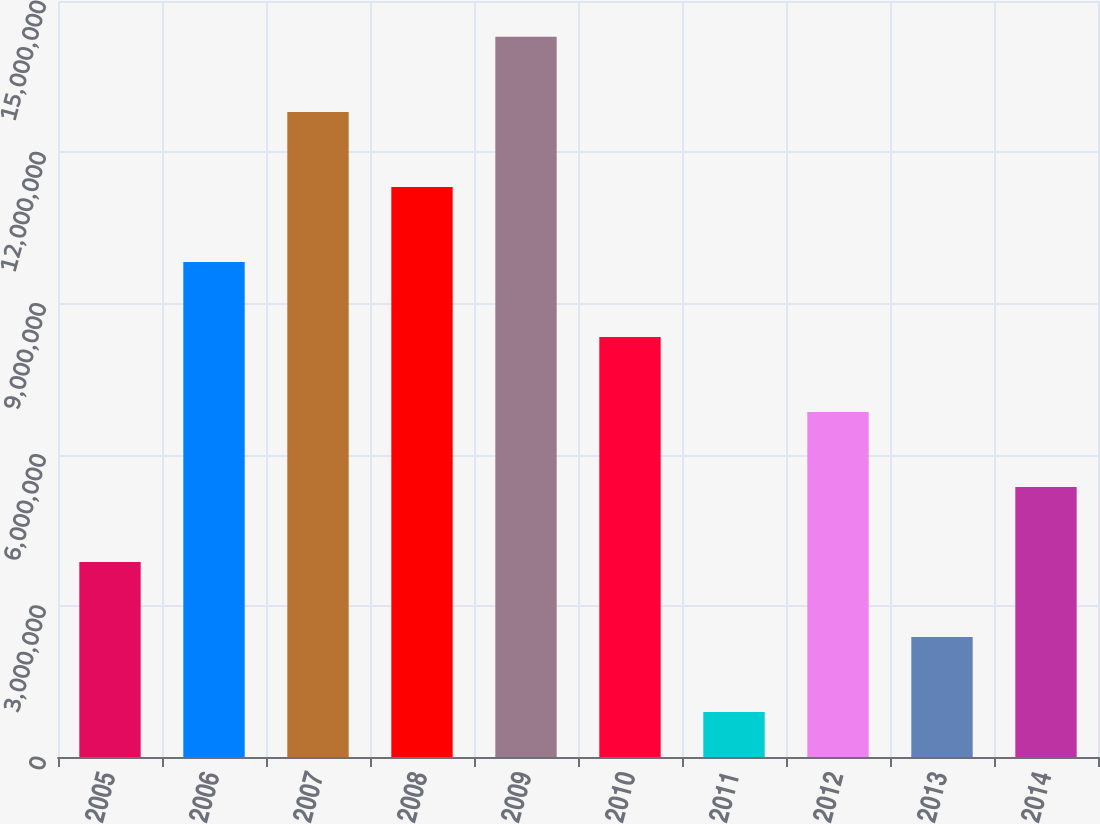Convert chart. <chart><loc_0><loc_0><loc_500><loc_500><bar_chart><fcel>2005<fcel>2006<fcel>2007<fcel>2008<fcel>2009<fcel>2010<fcel>2011<fcel>2012<fcel>2013<fcel>2014<nl><fcel>3.869e+06<fcel>9.823e+06<fcel>1.28e+07<fcel>1.13115e+07<fcel>1.42885e+07<fcel>8.3345e+06<fcel>892000<fcel>6.846e+06<fcel>2.3805e+06<fcel>5.3575e+06<nl></chart> 